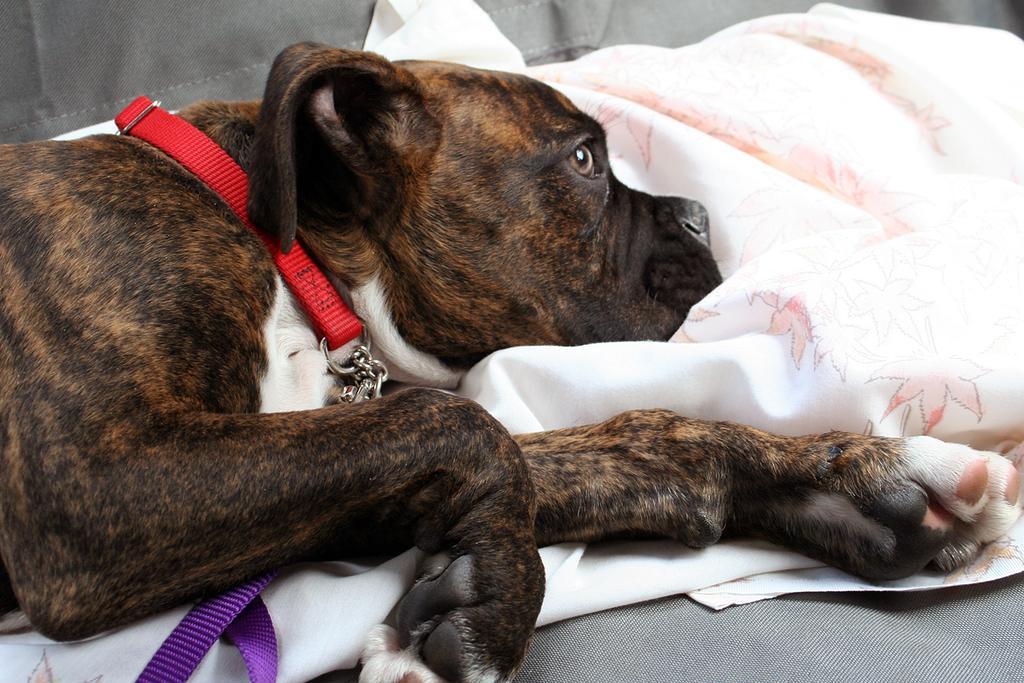In one or two sentences, can you explain what this image depicts? In this image in the center there is one dog and beside the dog there is one blanket, and at the bottom there is a couch. 